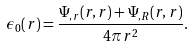<formula> <loc_0><loc_0><loc_500><loc_500>\epsilon _ { 0 } ( r ) = \frac { \Psi _ { , r } ( r , r ) + \Psi _ { , R } ( r , r ) } { 4 \pi r ^ { 2 } } .</formula> 